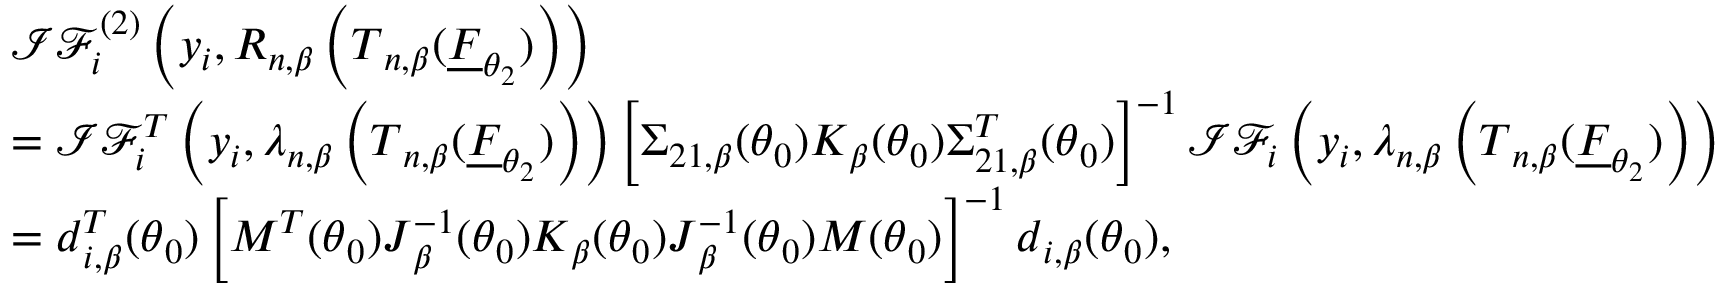<formula> <loc_0><loc_0><loc_500><loc_500>\begin{array} { r l } & { \mathcal { I F } _ { i } ^ { ( 2 ) } \left ( y _ { i } , R _ { n , \beta } \left ( T _ { n , \beta } ( \underline { F } _ { \theta _ { 2 } } ) \right ) \right ) } \\ & { = \mathcal { I F } _ { i } ^ { T } \left ( y _ { i } , \lambda _ { n , \beta } \left ( T _ { n , \beta } ( \underline { F } _ { \theta _ { 2 } } ) \right ) \right ) \left [ \Sigma _ { 2 1 , \beta } ( \theta _ { 0 } ) K _ { \beta } ( \theta _ { 0 } ) \Sigma _ { 2 1 , \beta } ^ { T } ( \theta _ { 0 } ) \right ] ^ { - 1 } \mathcal { I F } _ { i } \left ( y _ { i } , \lambda _ { n , \beta } \left ( T _ { n , \beta } ( \underline { F } _ { \theta _ { 2 } } ) \right ) \right ) } \\ & { = d _ { i , \beta } ^ { T } ( \theta _ { 0 } ) \left [ M ^ { T } ( \theta _ { 0 } ) J _ { \beta } ^ { - 1 } ( \theta _ { 0 } ) K _ { \beta } ( \theta _ { 0 } ) J _ { \beta } ^ { - 1 } ( \theta _ { 0 } ) M ( \theta _ { 0 } ) \right ] ^ { - 1 } d _ { i , \beta } ( \theta _ { 0 } ) , } \end{array}</formula> 